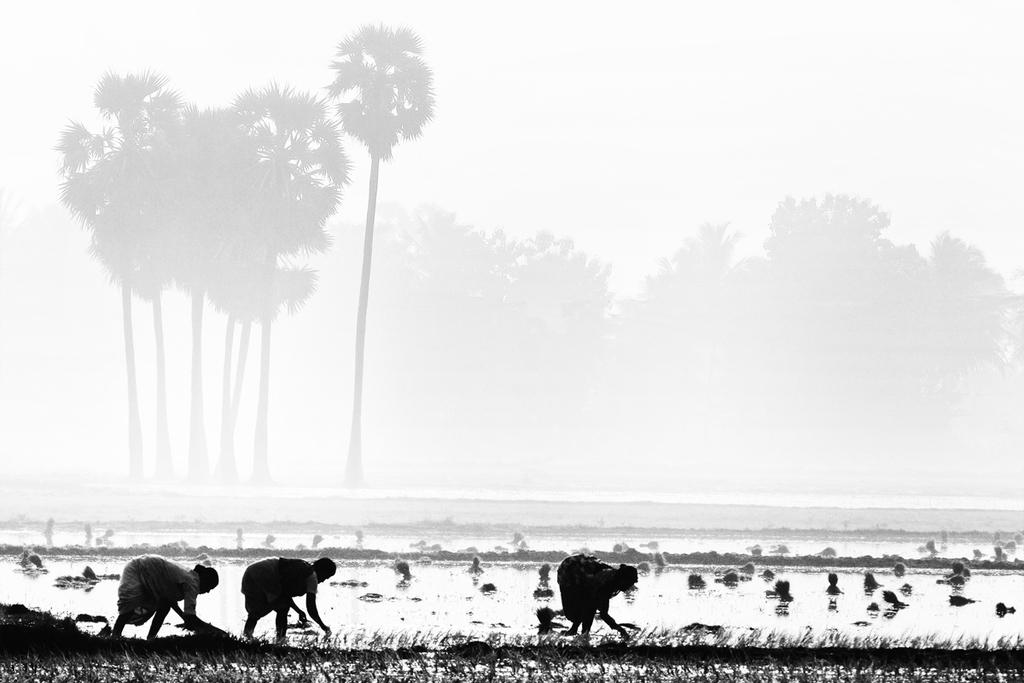What is happening in the field in the image? There are people in the field in the image. What can be seen in the background of the image? There is fog, many trees, and the sky visible in the background of the image. What type of grape is being used in the apparatus in the image? There is no grape or apparatus present in the image. How many bulbs are visible in the image? There are no bulbs present in the image. 